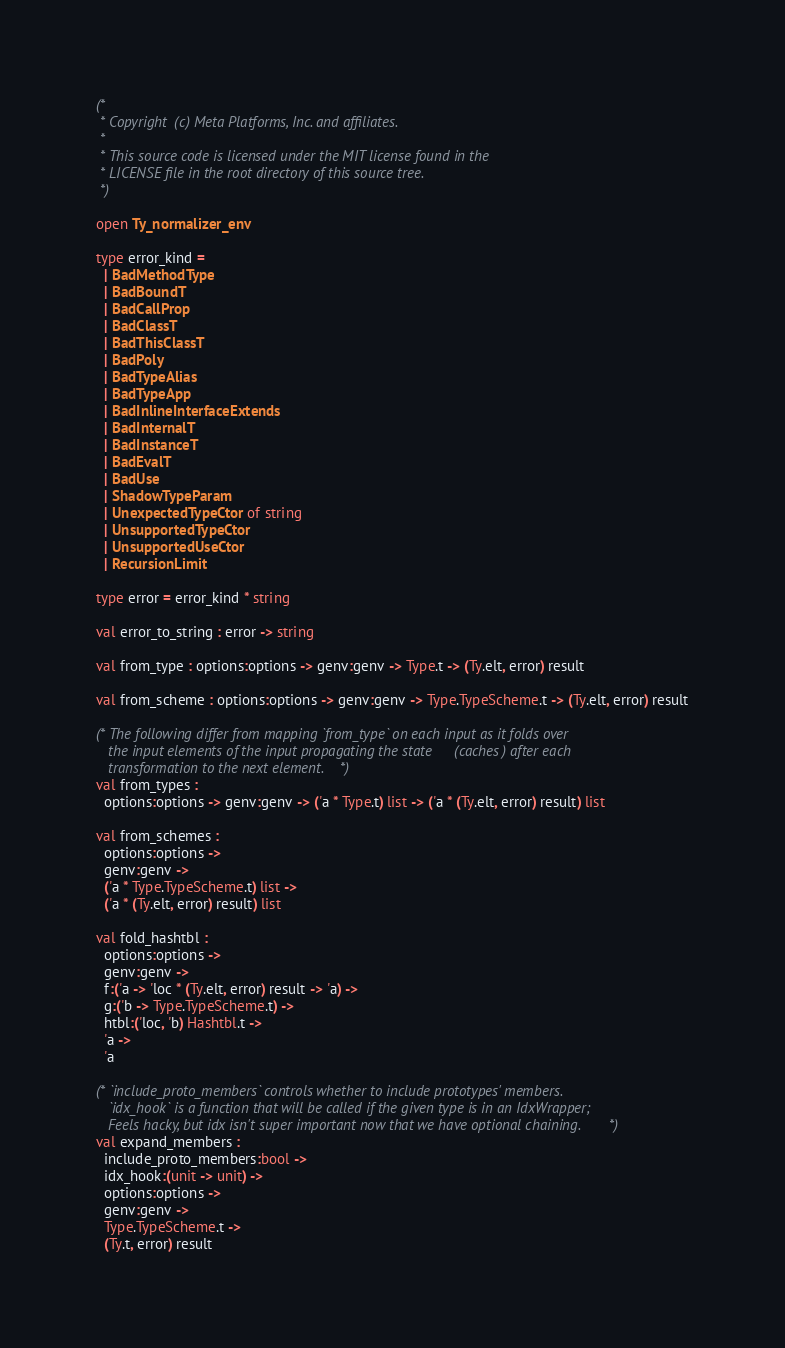<code> <loc_0><loc_0><loc_500><loc_500><_OCaml_>(*
 * Copyright (c) Meta Platforms, Inc. and affiliates.
 *
 * This source code is licensed under the MIT license found in the
 * LICENSE file in the root directory of this source tree.
 *)

open Ty_normalizer_env

type error_kind =
  | BadMethodType
  | BadBoundT
  | BadCallProp
  | BadClassT
  | BadThisClassT
  | BadPoly
  | BadTypeAlias
  | BadTypeApp
  | BadInlineInterfaceExtends
  | BadInternalT
  | BadInstanceT
  | BadEvalT
  | BadUse
  | ShadowTypeParam
  | UnexpectedTypeCtor of string
  | UnsupportedTypeCtor
  | UnsupportedUseCtor
  | RecursionLimit

type error = error_kind * string

val error_to_string : error -> string

val from_type : options:options -> genv:genv -> Type.t -> (Ty.elt, error) result

val from_scheme : options:options -> genv:genv -> Type.TypeScheme.t -> (Ty.elt, error) result

(* The following differ from mapping `from_type` on each input as it folds over
   the input elements of the input propagating the state (caches) after each
   transformation to the next element. *)
val from_types :
  options:options -> genv:genv -> ('a * Type.t) list -> ('a * (Ty.elt, error) result) list

val from_schemes :
  options:options ->
  genv:genv ->
  ('a * Type.TypeScheme.t) list ->
  ('a * (Ty.elt, error) result) list

val fold_hashtbl :
  options:options ->
  genv:genv ->
  f:('a -> 'loc * (Ty.elt, error) result -> 'a) ->
  g:('b -> Type.TypeScheme.t) ->
  htbl:('loc, 'b) Hashtbl.t ->
  'a ->
  'a

(* `include_proto_members` controls whether to include prototypes' members.
   `idx_hook` is a function that will be called if the given type is in an IdxWrapper;
   Feels hacky, but idx isn't super important now that we have optional chaining. *)
val expand_members :
  include_proto_members:bool ->
  idx_hook:(unit -> unit) ->
  options:options ->
  genv:genv ->
  Type.TypeScheme.t ->
  (Ty.t, error) result
</code> 